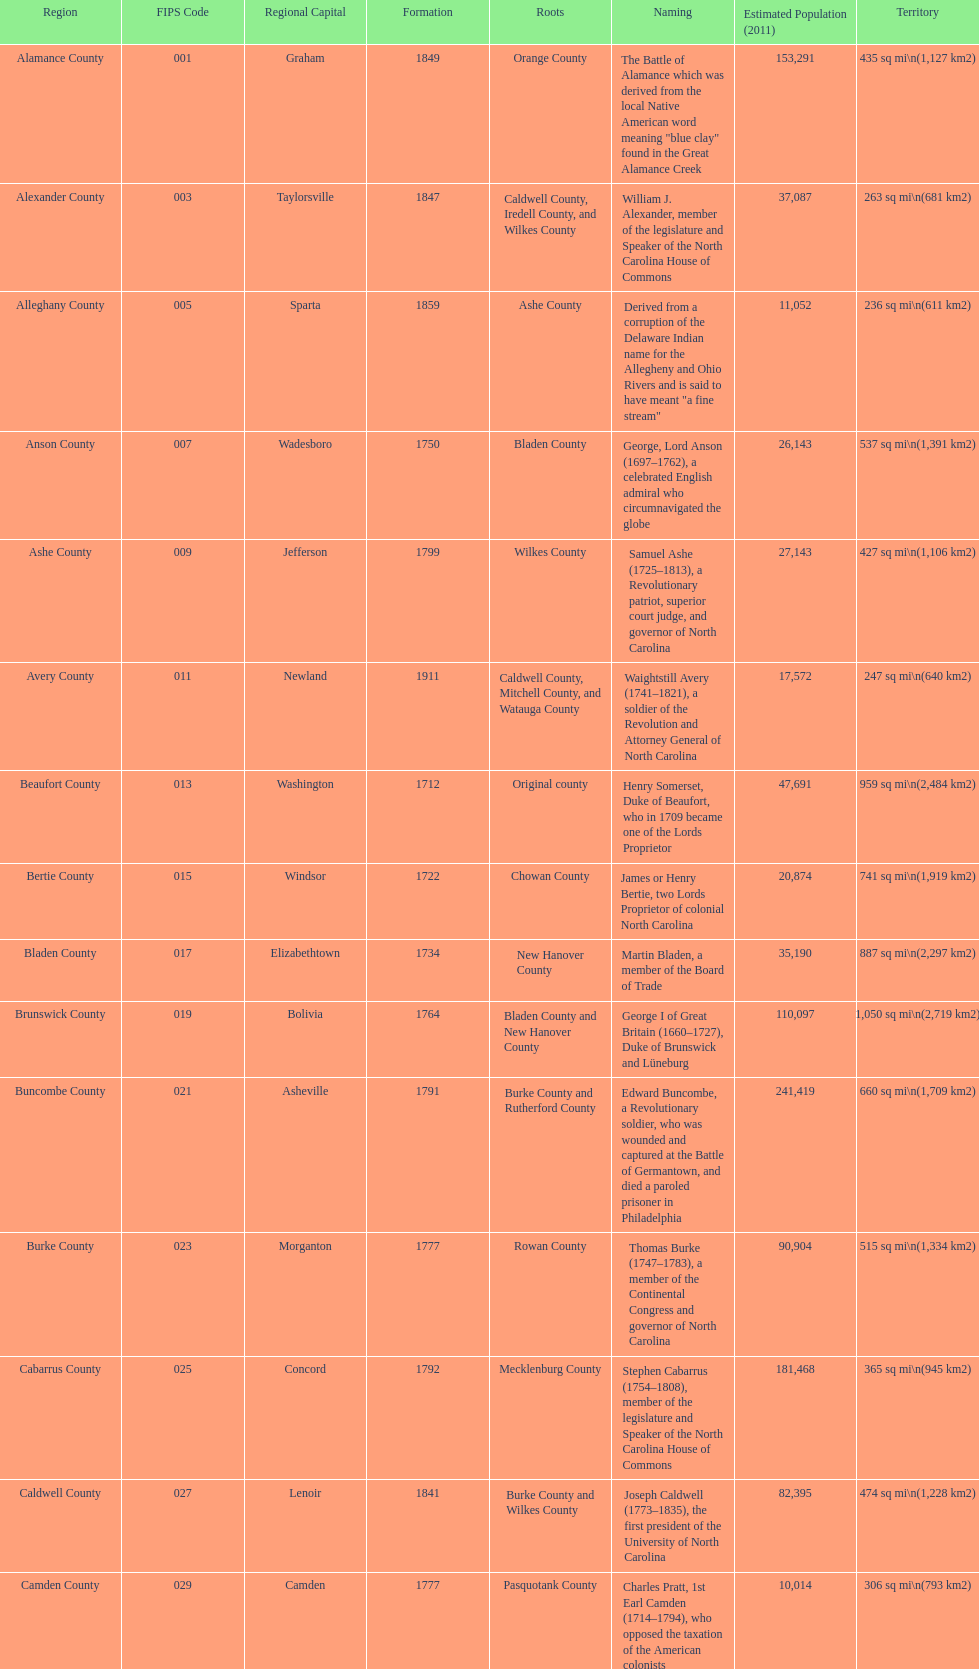Which county has a higher population, alamance or alexander? Alamance County. 